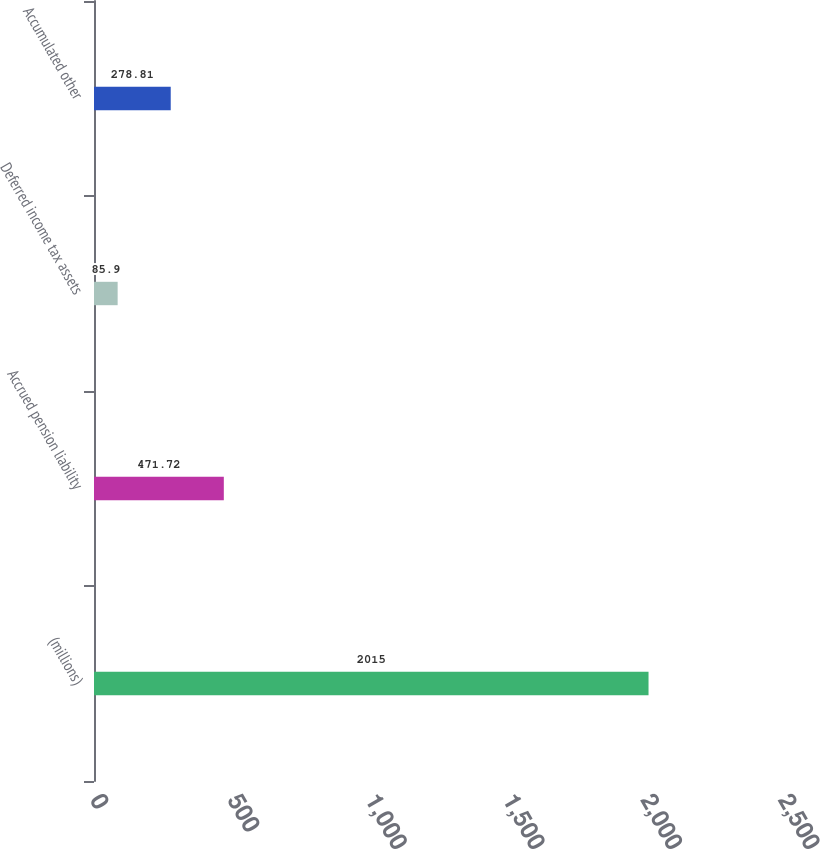Convert chart. <chart><loc_0><loc_0><loc_500><loc_500><bar_chart><fcel>(millions)<fcel>Accrued pension liability<fcel>Deferred income tax assets<fcel>Accumulated other<nl><fcel>2015<fcel>471.72<fcel>85.9<fcel>278.81<nl></chart> 